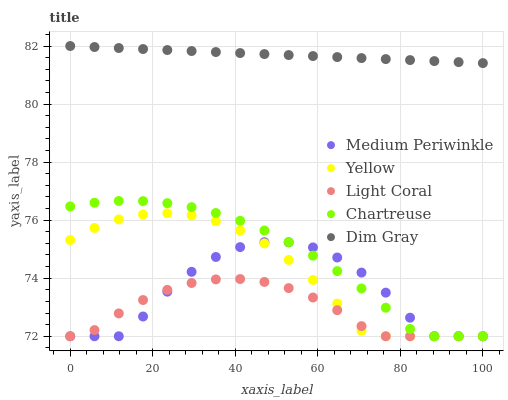Does Light Coral have the minimum area under the curve?
Answer yes or no. Yes. Does Dim Gray have the maximum area under the curve?
Answer yes or no. Yes. Does Chartreuse have the minimum area under the curve?
Answer yes or no. No. Does Chartreuse have the maximum area under the curve?
Answer yes or no. No. Is Dim Gray the smoothest?
Answer yes or no. Yes. Is Medium Periwinkle the roughest?
Answer yes or no. Yes. Is Chartreuse the smoothest?
Answer yes or no. No. Is Chartreuse the roughest?
Answer yes or no. No. Does Light Coral have the lowest value?
Answer yes or no. Yes. Does Dim Gray have the lowest value?
Answer yes or no. No. Does Dim Gray have the highest value?
Answer yes or no. Yes. Does Chartreuse have the highest value?
Answer yes or no. No. Is Light Coral less than Dim Gray?
Answer yes or no. Yes. Is Dim Gray greater than Medium Periwinkle?
Answer yes or no. Yes. Does Yellow intersect Medium Periwinkle?
Answer yes or no. Yes. Is Yellow less than Medium Periwinkle?
Answer yes or no. No. Is Yellow greater than Medium Periwinkle?
Answer yes or no. No. Does Light Coral intersect Dim Gray?
Answer yes or no. No. 